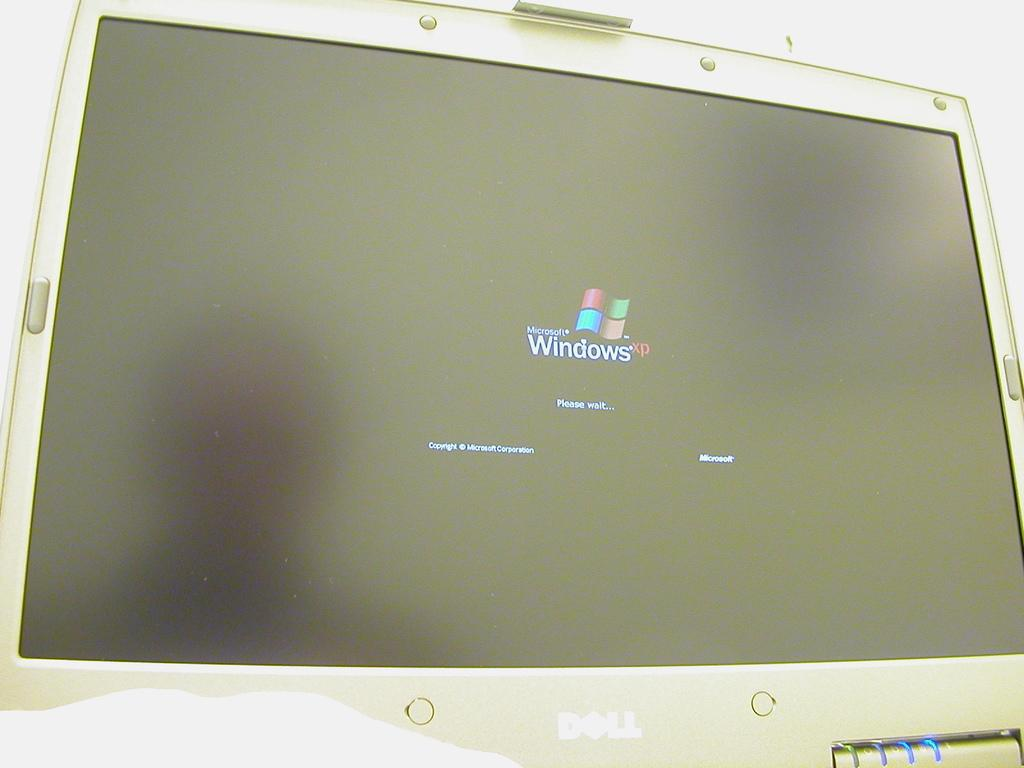<image>
Present a compact description of the photo's key features. The computer screen shown is showing a windows logo. 